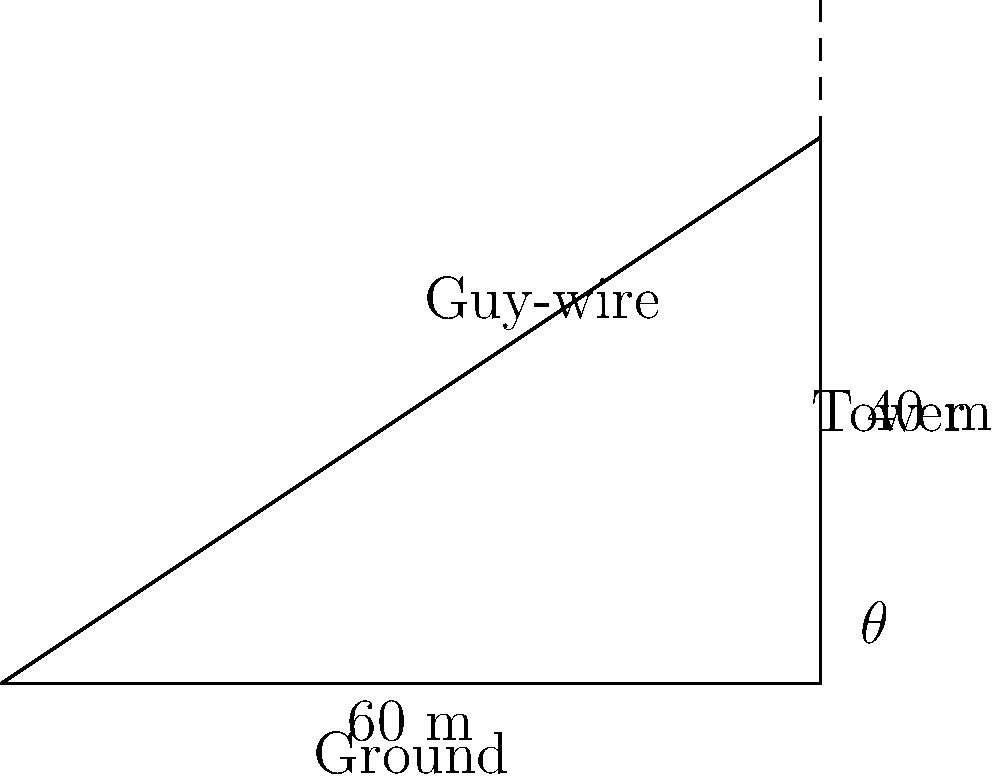In Jon Carsman's hometown, a new radio tower is being erected. The tower is 40 meters tall and needs to be supported by a guy-wire. The anchor point for the guy-wire is 60 meters from the base of the tower. What is the length of the guy-wire needed to reach from the anchor point to the top of the tower? Round your answer to the nearest meter. Let's approach this step-by-step using right triangle trigonometry:

1) We can see that this forms a right triangle, where:
   - The base (adjacent to the angle) is 60 meters
   - The height (opposite to the angle) is 40 meters
   - The guy-wire forms the hypotenuse

2) To find the length of the hypotenuse (guy-wire), we can use the Pythagorean theorem:

   $a^2 + b^2 = c^2$

   Where $a$ is the base, $b$ is the height, and $c$ is the hypotenuse.

3) Plugging in our values:

   $60^2 + 40^2 = c^2$

4) Simplify:

   $3600 + 1600 = c^2$
   $5200 = c^2$

5) Take the square root of both sides:

   $\sqrt{5200} = c$

6) Calculate:

   $c \approx 72.11$ meters

7) Rounding to the nearest meter:

   $c \approx 72$ meters
Answer: 72 meters 